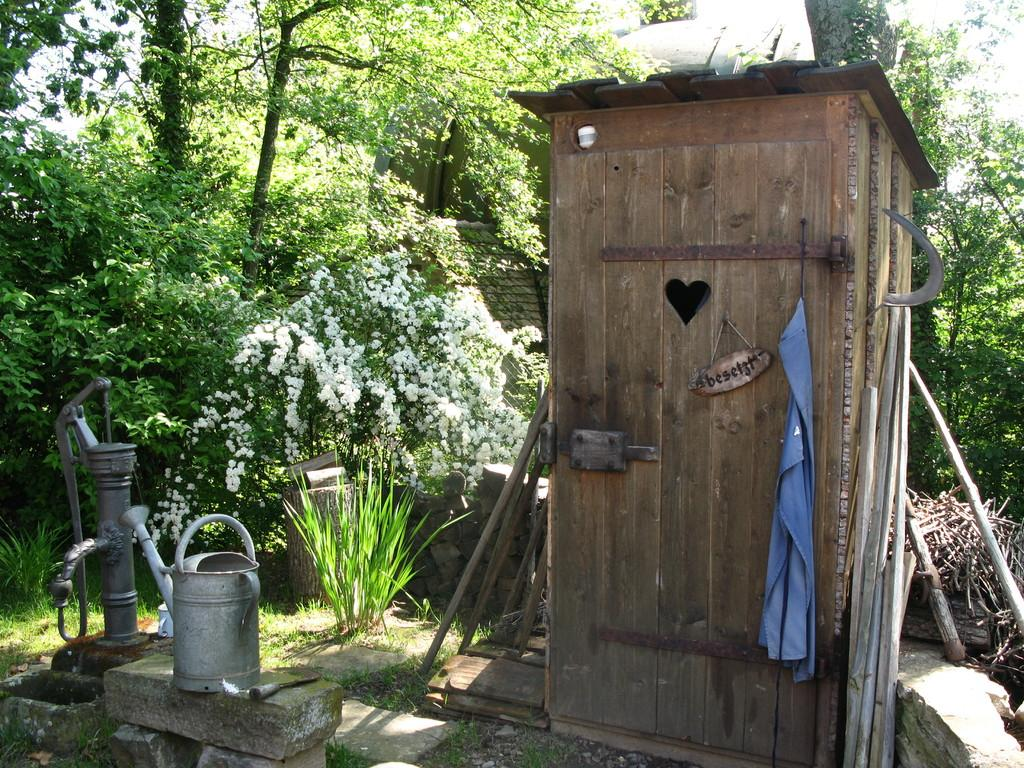What type of structure is present in the image? There is a wooden toilet shed in the image. What is another object related to water that can be seen in the image? There is a water pump in the image. What is the third object related to water in the image? There is a water bucket in the image. What type of plants are present in the image? There are white color flower plants in the image. What type of natural vegetation can be seen in the image? There are trees in the image. What is the measurement of the side of the top of the water pump in the image? There is no specific measurement provided for the side of the top of the water pump in the image. Additionally, the question itself is not relevant to the image, as it asks for a measurement that is not mentioned in the facts. 